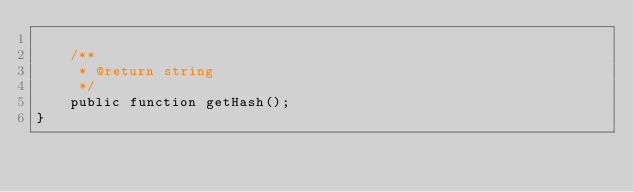Convert code to text. <code><loc_0><loc_0><loc_500><loc_500><_PHP_>
    /**
     * @return string
     */
    public function getHash();
}
</code> 